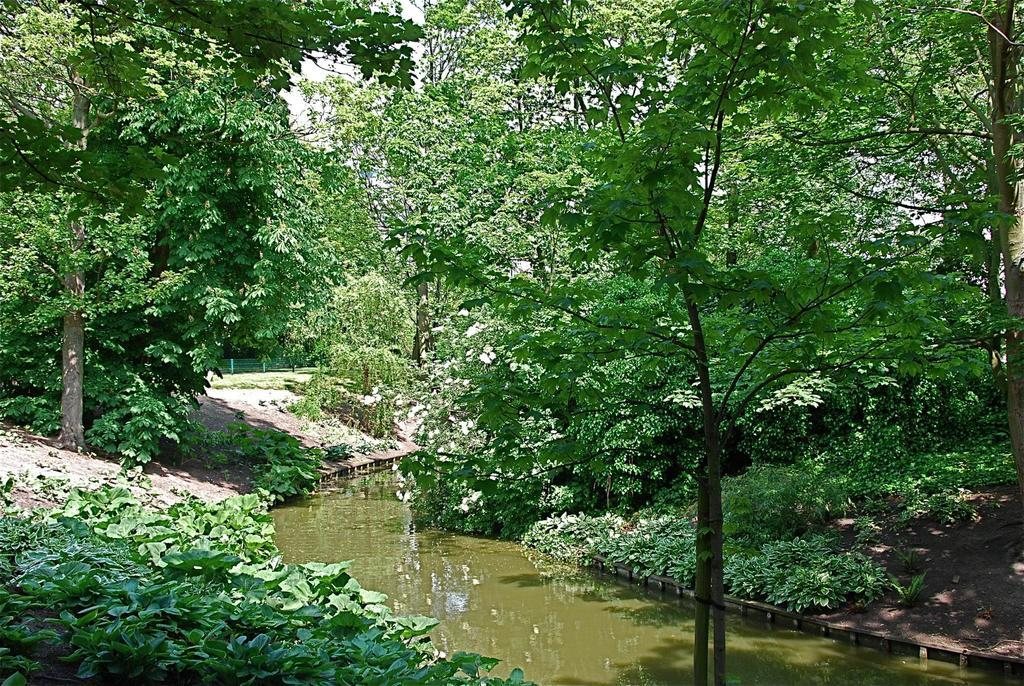What is in the foreground of the image? There is water in the foreground of the image. What type of vegetation is present on either side of the water? There is greenery on either side of the water. What can be seen in the background of the image? The sky is visible in the background of the image. How many socks are visible in the image? There are no socks present in the image. What type of clover can be seen growing near the water? There is no clover visible in the image; only greenery is mentioned. 